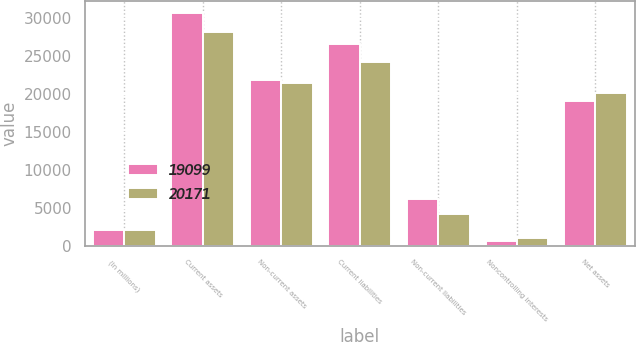Convert chart to OTSL. <chart><loc_0><loc_0><loc_500><loc_500><stacked_bar_chart><ecel><fcel>(In millions)<fcel>Current assets<fcel>Non-current assets<fcel>Current liabilities<fcel>Non-current liabilities<fcel>Noncontrolling interests<fcel>Net assets<nl><fcel>19099<fcel>2018<fcel>30732<fcel>21841<fcel>26592<fcel>6205<fcel>677<fcel>19099<nl><fcel>20171<fcel>2017<fcel>28200<fcel>21411<fcel>24209<fcel>4250<fcel>981<fcel>20171<nl></chart> 